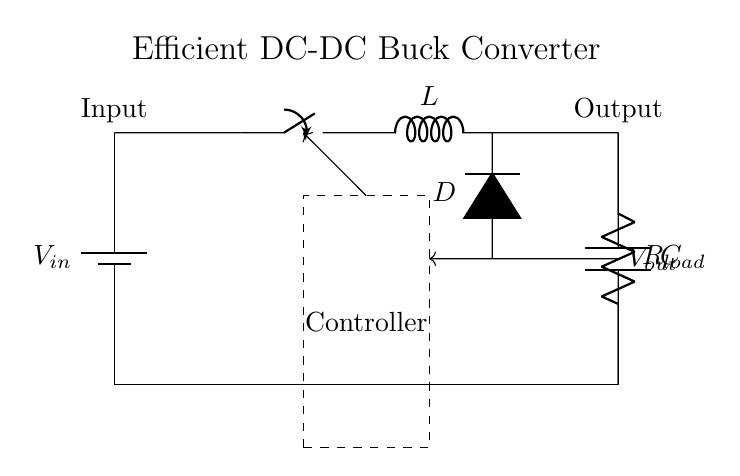What type of circuit is this? This circuit is a DC-DC buck converter, which steps down voltage from the input source to a lower output voltage. The key indicators are the inductor and switch configurations that are characteristic of buck converters.
Answer: DC-DC buck converter What is the function of the switch in this circuit? The switch controls the flow of current, allowing it to turn on and off, which facilitates the energy storage in the inductor. When closed, it connects the input voltage to the inductor and when open, it allows the inductor to discharge to the output.
Answer: Control current flow What component is used for energy storage in this circuit? The inductor is used for energy storage. It stores energy when the switch is closed and releases it when the switch is opened, thus contributing to the conversion process.
Answer: Inductor What role does the diode play in this circuit? The diode allows current to flow in only one direction, which is crucial for maintaining current flow to the load when the switch is open. It prevents backflow and ensures the energy stored in the inductor is transferred to the output capacitor and load.
Answer: Current direction control What is the load resistance represented in the circuit? The load resistance is represented as R load connected to the output of the converter. It is a crucial component as it determines how much current is drawn by the appliance.
Answer: R load What does the dashed rectangle represent in the diagram? The dashed rectangle represents the controller of the circuit, which regulates its operation, including controlling the duty cycle of the switch based on feedback from the output voltage.
Answer: Controller 